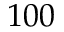Convert formula to latex. <formula><loc_0><loc_0><loc_500><loc_500>1 0 0</formula> 